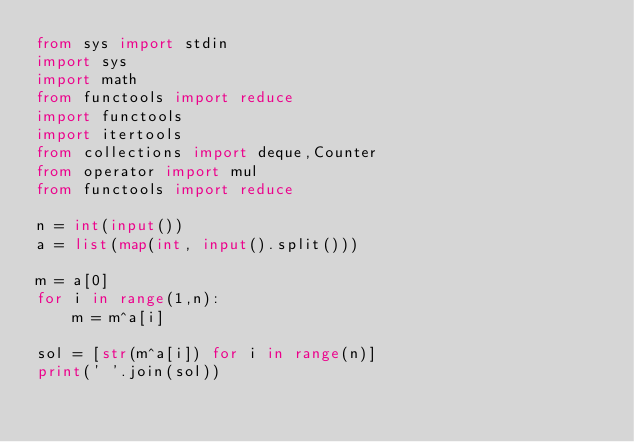<code> <loc_0><loc_0><loc_500><loc_500><_Python_>from sys import stdin
import sys
import math
from functools import reduce
import functools
import itertools
from collections import deque,Counter
from operator import mul
from functools import reduce

n = int(input())
a = list(map(int, input().split()))

m = a[0]
for i in range(1,n):
    m = m^a[i]

sol = [str(m^a[i]) for i in range(n)]
print(' '.join(sol))
</code> 